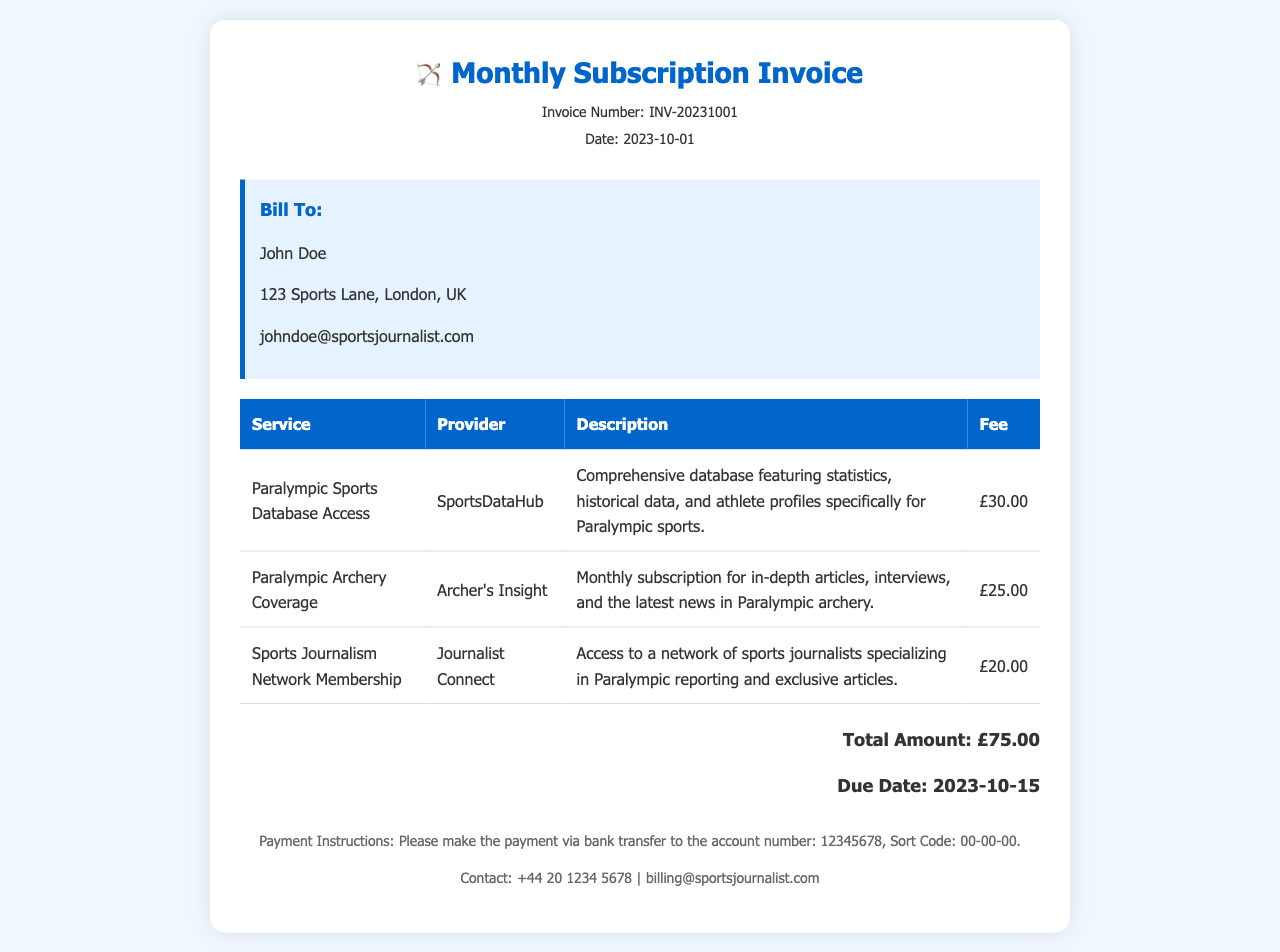What is the invoice number? The invoice number is located in the header section of the document.
Answer: INV-20231001 What is the total amount due? The total amount is stated in the total section of the document.
Answer: £75.00 Who is the bill recipient? The "Bill To" section lists the recipient's name.
Answer: John Doe What is the due date for payment? The due date for payment is mentioned in the total section of the document.
Answer: 2023-10-15 Which provider offers access to the Paralympic Sports Database? The provider's name for the Paralympic Sports Database is listed in the service table.
Answer: SportsDataHub How much does the Paralympic Archery Coverage cost? The fee for the Paralympic Archery Coverage is specified in the service table.
Answer: £25.00 What type of coverage does Archer's Insight provide? The description of the service indicates what type of coverage is offered.
Answer: In-depth articles, interviews, and the latest news in Paralympic archery What payment method is required? The payment instructions outline how to make the payment.
Answer: Bank transfer How many services are listed in the invoice? The services are listed in the table, requiring counting the rows of the table.
Answer: 3 